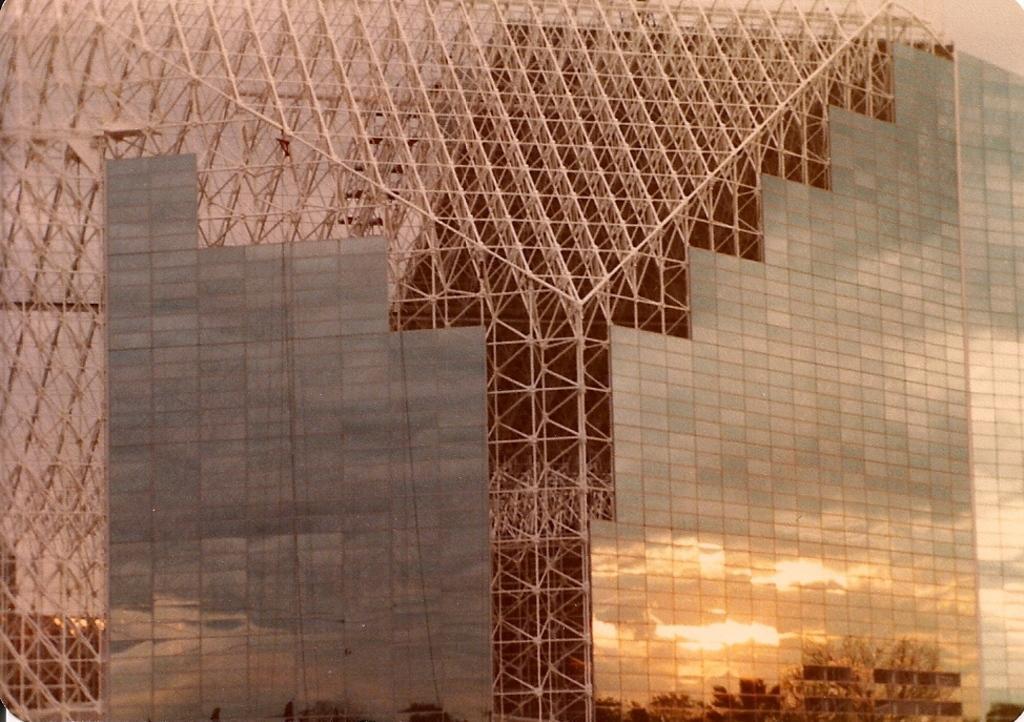In one or two sentences, can you explain what this image depicts? In this picture we can see few metal rods and glasses, in the mirror reflection we can find few trees. 